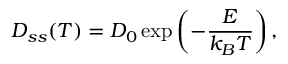<formula> <loc_0><loc_0><loc_500><loc_500>D _ { s s } ( T ) = D _ { 0 } \exp \left ( - \frac { E } { k _ { B } T } \right ) ,</formula> 